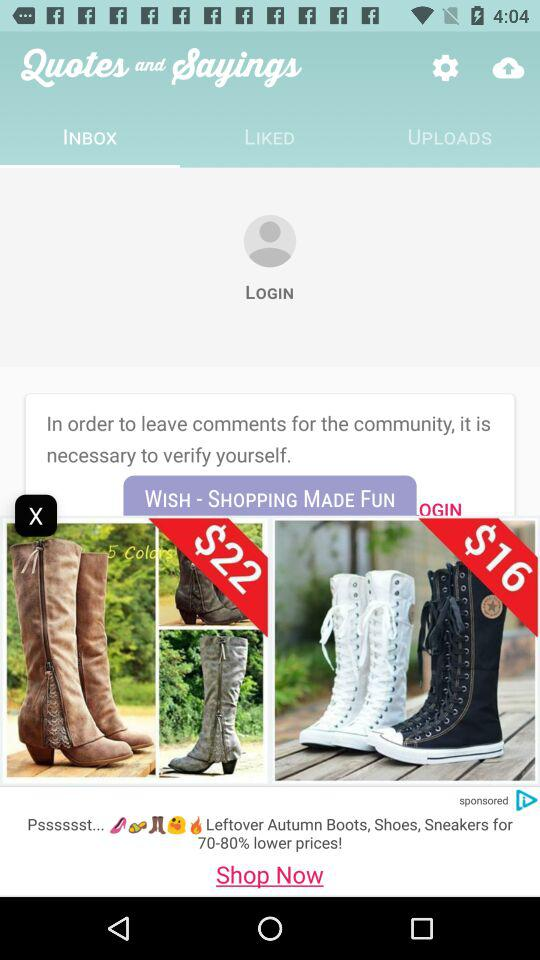How much more expensive are the cowboy boots than the converse chuck taylor lace up boots?
Answer the question using a single word or phrase. $6 